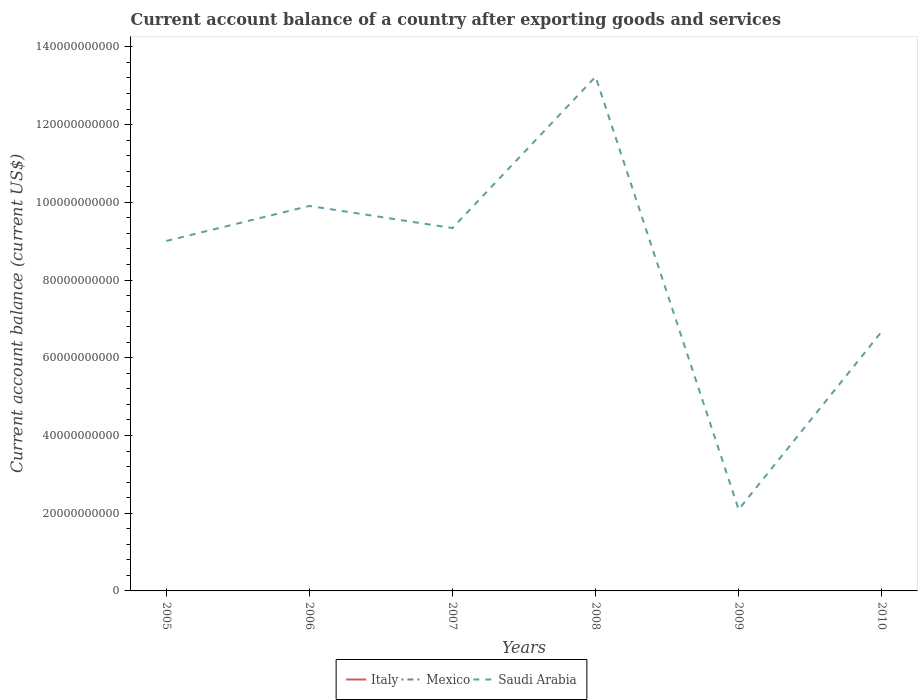Does the line corresponding to Saudi Arabia intersect with the line corresponding to Italy?
Keep it short and to the point. No. Is the number of lines equal to the number of legend labels?
Your answer should be compact. No. Across all years, what is the maximum account balance in Saudi Arabia?
Make the answer very short. 2.10e+1. What is the total account balance in Saudi Arabia in the graph?
Your answer should be compact. -3.33e+1. Is the account balance in Italy strictly greater than the account balance in Saudi Arabia over the years?
Your answer should be very brief. Yes. Does the graph contain grids?
Offer a terse response. No. Where does the legend appear in the graph?
Your answer should be very brief. Bottom center. How many legend labels are there?
Your answer should be compact. 3. How are the legend labels stacked?
Provide a short and direct response. Horizontal. What is the title of the graph?
Your answer should be compact. Current account balance of a country after exporting goods and services. What is the label or title of the Y-axis?
Offer a very short reply. Current account balance (current US$). What is the Current account balance (current US$) of Mexico in 2005?
Give a very brief answer. 0. What is the Current account balance (current US$) of Saudi Arabia in 2005?
Give a very brief answer. 9.01e+1. What is the Current account balance (current US$) in Italy in 2006?
Make the answer very short. 0. What is the Current account balance (current US$) of Saudi Arabia in 2006?
Your answer should be very brief. 9.91e+1. What is the Current account balance (current US$) of Mexico in 2007?
Ensure brevity in your answer.  0. What is the Current account balance (current US$) in Saudi Arabia in 2007?
Provide a short and direct response. 9.34e+1. What is the Current account balance (current US$) of Saudi Arabia in 2008?
Provide a succinct answer. 1.32e+11. What is the Current account balance (current US$) of Italy in 2009?
Your answer should be very brief. 0. What is the Current account balance (current US$) in Mexico in 2009?
Your response must be concise. 0. What is the Current account balance (current US$) in Saudi Arabia in 2009?
Provide a succinct answer. 2.10e+1. What is the Current account balance (current US$) in Mexico in 2010?
Ensure brevity in your answer.  0. What is the Current account balance (current US$) of Saudi Arabia in 2010?
Your answer should be compact. 6.68e+1. Across all years, what is the maximum Current account balance (current US$) of Saudi Arabia?
Give a very brief answer. 1.32e+11. Across all years, what is the minimum Current account balance (current US$) of Saudi Arabia?
Give a very brief answer. 2.10e+1. What is the total Current account balance (current US$) of Italy in the graph?
Your response must be concise. 0. What is the total Current account balance (current US$) of Saudi Arabia in the graph?
Keep it short and to the point. 5.03e+11. What is the difference between the Current account balance (current US$) in Saudi Arabia in 2005 and that in 2006?
Offer a terse response. -9.01e+09. What is the difference between the Current account balance (current US$) in Saudi Arabia in 2005 and that in 2007?
Offer a terse response. -3.32e+09. What is the difference between the Current account balance (current US$) of Saudi Arabia in 2005 and that in 2008?
Your answer should be compact. -4.23e+1. What is the difference between the Current account balance (current US$) in Saudi Arabia in 2005 and that in 2009?
Your response must be concise. 6.91e+1. What is the difference between the Current account balance (current US$) in Saudi Arabia in 2005 and that in 2010?
Provide a succinct answer. 2.33e+1. What is the difference between the Current account balance (current US$) of Saudi Arabia in 2006 and that in 2007?
Keep it short and to the point. 5.69e+09. What is the difference between the Current account balance (current US$) in Saudi Arabia in 2006 and that in 2008?
Keep it short and to the point. -3.33e+1. What is the difference between the Current account balance (current US$) of Saudi Arabia in 2006 and that in 2009?
Offer a very short reply. 7.81e+1. What is the difference between the Current account balance (current US$) in Saudi Arabia in 2006 and that in 2010?
Provide a succinct answer. 3.23e+1. What is the difference between the Current account balance (current US$) in Saudi Arabia in 2007 and that in 2008?
Provide a succinct answer. -3.89e+1. What is the difference between the Current account balance (current US$) of Saudi Arabia in 2007 and that in 2009?
Your response must be concise. 7.24e+1. What is the difference between the Current account balance (current US$) of Saudi Arabia in 2007 and that in 2010?
Keep it short and to the point. 2.66e+1. What is the difference between the Current account balance (current US$) in Saudi Arabia in 2008 and that in 2009?
Offer a very short reply. 1.11e+11. What is the difference between the Current account balance (current US$) in Saudi Arabia in 2008 and that in 2010?
Your answer should be very brief. 6.56e+1. What is the difference between the Current account balance (current US$) in Saudi Arabia in 2009 and that in 2010?
Offer a very short reply. -4.58e+1. What is the average Current account balance (current US$) in Italy per year?
Provide a short and direct response. 0. What is the average Current account balance (current US$) of Mexico per year?
Your response must be concise. 0. What is the average Current account balance (current US$) of Saudi Arabia per year?
Make the answer very short. 8.38e+1. What is the ratio of the Current account balance (current US$) of Saudi Arabia in 2005 to that in 2007?
Give a very brief answer. 0.96. What is the ratio of the Current account balance (current US$) of Saudi Arabia in 2005 to that in 2008?
Your answer should be compact. 0.68. What is the ratio of the Current account balance (current US$) in Saudi Arabia in 2005 to that in 2009?
Your answer should be very brief. 4.3. What is the ratio of the Current account balance (current US$) of Saudi Arabia in 2005 to that in 2010?
Give a very brief answer. 1.35. What is the ratio of the Current account balance (current US$) of Saudi Arabia in 2006 to that in 2007?
Your answer should be very brief. 1.06. What is the ratio of the Current account balance (current US$) in Saudi Arabia in 2006 to that in 2008?
Make the answer very short. 0.75. What is the ratio of the Current account balance (current US$) of Saudi Arabia in 2006 to that in 2009?
Keep it short and to the point. 4.73. What is the ratio of the Current account balance (current US$) of Saudi Arabia in 2006 to that in 2010?
Provide a short and direct response. 1.48. What is the ratio of the Current account balance (current US$) in Saudi Arabia in 2007 to that in 2008?
Provide a succinct answer. 0.71. What is the ratio of the Current account balance (current US$) of Saudi Arabia in 2007 to that in 2009?
Keep it short and to the point. 4.46. What is the ratio of the Current account balance (current US$) in Saudi Arabia in 2007 to that in 2010?
Ensure brevity in your answer.  1.4. What is the ratio of the Current account balance (current US$) in Saudi Arabia in 2008 to that in 2009?
Your answer should be compact. 6.31. What is the ratio of the Current account balance (current US$) of Saudi Arabia in 2008 to that in 2010?
Make the answer very short. 1.98. What is the ratio of the Current account balance (current US$) in Saudi Arabia in 2009 to that in 2010?
Your response must be concise. 0.31. What is the difference between the highest and the second highest Current account balance (current US$) of Saudi Arabia?
Provide a short and direct response. 3.33e+1. What is the difference between the highest and the lowest Current account balance (current US$) in Saudi Arabia?
Your response must be concise. 1.11e+11. 